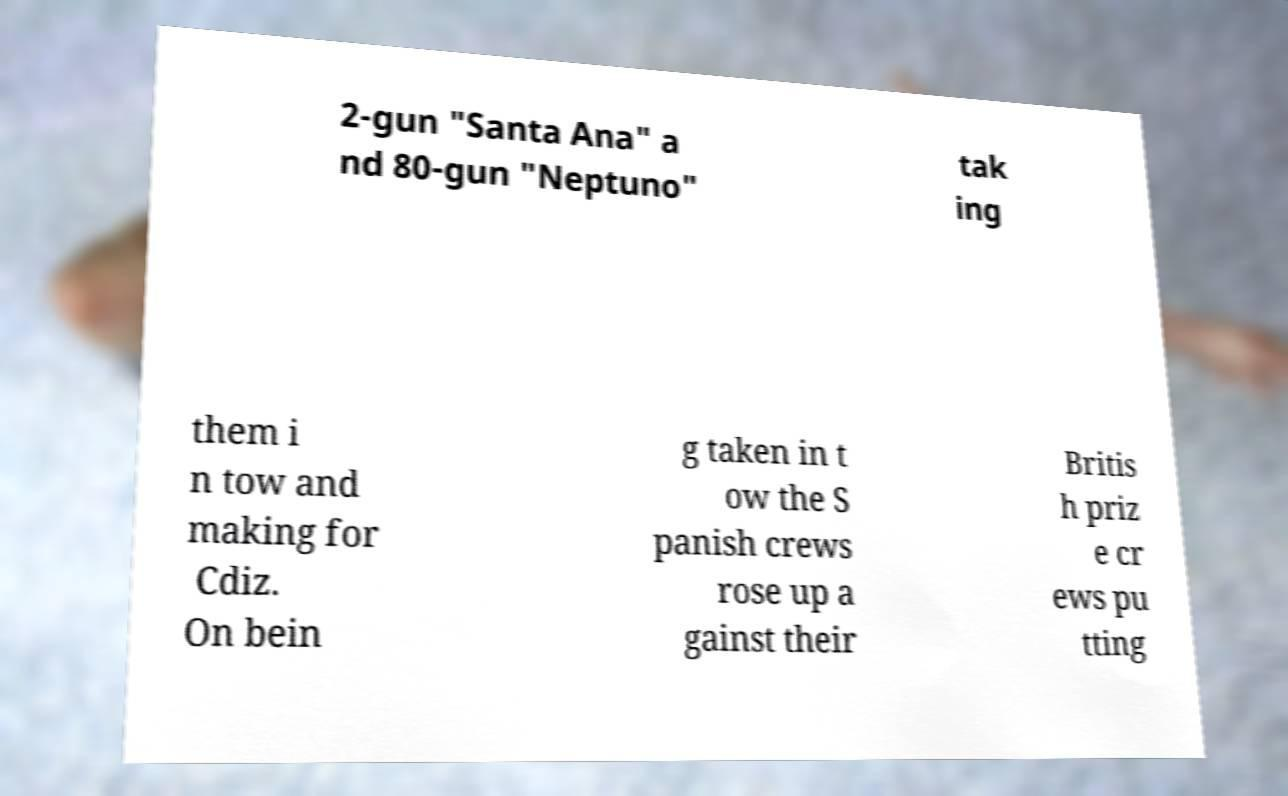What messages or text are displayed in this image? I need them in a readable, typed format. 2-gun "Santa Ana" a nd 80-gun "Neptuno" tak ing them i n tow and making for Cdiz. On bein g taken in t ow the S panish crews rose up a gainst their Britis h priz e cr ews pu tting 